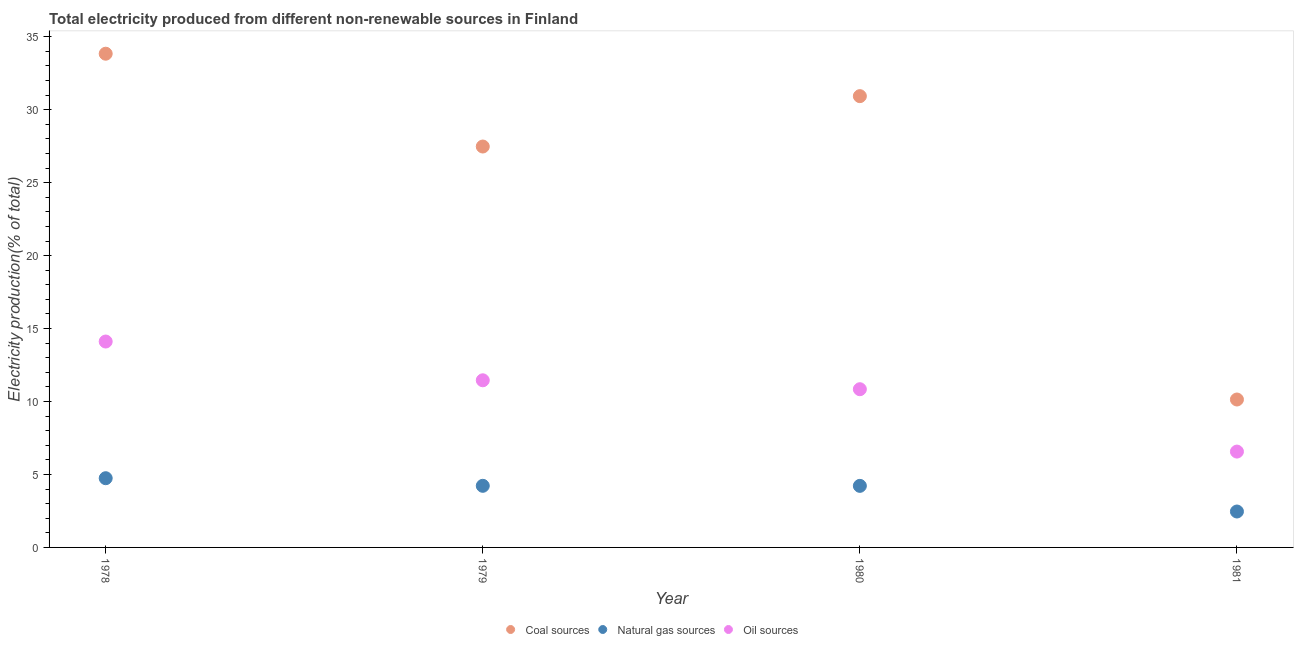What is the percentage of electricity produced by coal in 1981?
Your response must be concise. 10.14. Across all years, what is the maximum percentage of electricity produced by coal?
Offer a very short reply. 33.84. Across all years, what is the minimum percentage of electricity produced by natural gas?
Your response must be concise. 2.46. In which year was the percentage of electricity produced by natural gas maximum?
Provide a succinct answer. 1978. What is the total percentage of electricity produced by natural gas in the graph?
Your answer should be very brief. 15.65. What is the difference between the percentage of electricity produced by oil sources in 1980 and that in 1981?
Your answer should be compact. 4.27. What is the difference between the percentage of electricity produced by natural gas in 1979 and the percentage of electricity produced by coal in 1978?
Provide a short and direct response. -29.61. What is the average percentage of electricity produced by coal per year?
Provide a short and direct response. 25.59. In the year 1978, what is the difference between the percentage of electricity produced by natural gas and percentage of electricity produced by coal?
Give a very brief answer. -29.09. What is the ratio of the percentage of electricity produced by coal in 1979 to that in 1980?
Your answer should be compact. 0.89. Is the difference between the percentage of electricity produced by oil sources in 1980 and 1981 greater than the difference between the percentage of electricity produced by natural gas in 1980 and 1981?
Provide a short and direct response. Yes. What is the difference between the highest and the second highest percentage of electricity produced by coal?
Give a very brief answer. 2.91. What is the difference between the highest and the lowest percentage of electricity produced by coal?
Make the answer very short. 23.7. In how many years, is the percentage of electricity produced by oil sources greater than the average percentage of electricity produced by oil sources taken over all years?
Keep it short and to the point. 3. Is the sum of the percentage of electricity produced by natural gas in 1978 and 1979 greater than the maximum percentage of electricity produced by coal across all years?
Give a very brief answer. No. Is the percentage of electricity produced by natural gas strictly greater than the percentage of electricity produced by oil sources over the years?
Provide a short and direct response. No. How many years are there in the graph?
Make the answer very short. 4. What is the difference between two consecutive major ticks on the Y-axis?
Your answer should be very brief. 5. Are the values on the major ticks of Y-axis written in scientific E-notation?
Give a very brief answer. No. Does the graph contain any zero values?
Provide a succinct answer. No. Does the graph contain grids?
Give a very brief answer. No. Where does the legend appear in the graph?
Your response must be concise. Bottom center. How are the legend labels stacked?
Give a very brief answer. Horizontal. What is the title of the graph?
Offer a terse response. Total electricity produced from different non-renewable sources in Finland. Does "Ages 15-20" appear as one of the legend labels in the graph?
Your response must be concise. No. What is the Electricity production(% of total) in Coal sources in 1978?
Your answer should be compact. 33.84. What is the Electricity production(% of total) of Natural gas sources in 1978?
Ensure brevity in your answer.  4.74. What is the Electricity production(% of total) in Oil sources in 1978?
Keep it short and to the point. 14.11. What is the Electricity production(% of total) in Coal sources in 1979?
Keep it short and to the point. 27.47. What is the Electricity production(% of total) in Natural gas sources in 1979?
Your answer should be compact. 4.22. What is the Electricity production(% of total) in Oil sources in 1979?
Offer a very short reply. 11.45. What is the Electricity production(% of total) in Coal sources in 1980?
Ensure brevity in your answer.  30.93. What is the Electricity production(% of total) in Natural gas sources in 1980?
Give a very brief answer. 4.22. What is the Electricity production(% of total) in Oil sources in 1980?
Ensure brevity in your answer.  10.84. What is the Electricity production(% of total) in Coal sources in 1981?
Your response must be concise. 10.14. What is the Electricity production(% of total) in Natural gas sources in 1981?
Your response must be concise. 2.46. What is the Electricity production(% of total) of Oil sources in 1981?
Provide a succinct answer. 6.57. Across all years, what is the maximum Electricity production(% of total) in Coal sources?
Make the answer very short. 33.84. Across all years, what is the maximum Electricity production(% of total) of Natural gas sources?
Your answer should be very brief. 4.74. Across all years, what is the maximum Electricity production(% of total) in Oil sources?
Offer a terse response. 14.11. Across all years, what is the minimum Electricity production(% of total) of Coal sources?
Keep it short and to the point. 10.14. Across all years, what is the minimum Electricity production(% of total) in Natural gas sources?
Offer a very short reply. 2.46. Across all years, what is the minimum Electricity production(% of total) in Oil sources?
Your answer should be very brief. 6.57. What is the total Electricity production(% of total) of Coal sources in the graph?
Your answer should be compact. 102.37. What is the total Electricity production(% of total) in Natural gas sources in the graph?
Offer a terse response. 15.65. What is the total Electricity production(% of total) of Oil sources in the graph?
Your response must be concise. 42.98. What is the difference between the Electricity production(% of total) of Coal sources in 1978 and that in 1979?
Provide a succinct answer. 6.36. What is the difference between the Electricity production(% of total) of Natural gas sources in 1978 and that in 1979?
Your response must be concise. 0.52. What is the difference between the Electricity production(% of total) of Oil sources in 1978 and that in 1979?
Offer a very short reply. 2.66. What is the difference between the Electricity production(% of total) of Coal sources in 1978 and that in 1980?
Provide a succinct answer. 2.91. What is the difference between the Electricity production(% of total) in Natural gas sources in 1978 and that in 1980?
Offer a terse response. 0.52. What is the difference between the Electricity production(% of total) in Oil sources in 1978 and that in 1980?
Offer a terse response. 3.27. What is the difference between the Electricity production(% of total) of Coal sources in 1978 and that in 1981?
Keep it short and to the point. 23.7. What is the difference between the Electricity production(% of total) of Natural gas sources in 1978 and that in 1981?
Offer a very short reply. 2.28. What is the difference between the Electricity production(% of total) in Oil sources in 1978 and that in 1981?
Your response must be concise. 7.54. What is the difference between the Electricity production(% of total) in Coal sources in 1979 and that in 1980?
Ensure brevity in your answer.  -3.45. What is the difference between the Electricity production(% of total) in Natural gas sources in 1979 and that in 1980?
Offer a terse response. 0. What is the difference between the Electricity production(% of total) of Oil sources in 1979 and that in 1980?
Ensure brevity in your answer.  0.61. What is the difference between the Electricity production(% of total) in Coal sources in 1979 and that in 1981?
Make the answer very short. 17.34. What is the difference between the Electricity production(% of total) in Natural gas sources in 1979 and that in 1981?
Provide a short and direct response. 1.76. What is the difference between the Electricity production(% of total) of Oil sources in 1979 and that in 1981?
Give a very brief answer. 4.89. What is the difference between the Electricity production(% of total) in Coal sources in 1980 and that in 1981?
Make the answer very short. 20.79. What is the difference between the Electricity production(% of total) in Natural gas sources in 1980 and that in 1981?
Make the answer very short. 1.76. What is the difference between the Electricity production(% of total) in Oil sources in 1980 and that in 1981?
Provide a short and direct response. 4.27. What is the difference between the Electricity production(% of total) in Coal sources in 1978 and the Electricity production(% of total) in Natural gas sources in 1979?
Keep it short and to the point. 29.61. What is the difference between the Electricity production(% of total) in Coal sources in 1978 and the Electricity production(% of total) in Oil sources in 1979?
Provide a succinct answer. 22.38. What is the difference between the Electricity production(% of total) of Natural gas sources in 1978 and the Electricity production(% of total) of Oil sources in 1979?
Offer a terse response. -6.71. What is the difference between the Electricity production(% of total) of Coal sources in 1978 and the Electricity production(% of total) of Natural gas sources in 1980?
Provide a succinct answer. 29.62. What is the difference between the Electricity production(% of total) in Coal sources in 1978 and the Electricity production(% of total) in Oil sources in 1980?
Offer a terse response. 22.99. What is the difference between the Electricity production(% of total) of Natural gas sources in 1978 and the Electricity production(% of total) of Oil sources in 1980?
Ensure brevity in your answer.  -6.1. What is the difference between the Electricity production(% of total) of Coal sources in 1978 and the Electricity production(% of total) of Natural gas sources in 1981?
Ensure brevity in your answer.  31.37. What is the difference between the Electricity production(% of total) of Coal sources in 1978 and the Electricity production(% of total) of Oil sources in 1981?
Provide a short and direct response. 27.27. What is the difference between the Electricity production(% of total) of Natural gas sources in 1978 and the Electricity production(% of total) of Oil sources in 1981?
Provide a succinct answer. -1.82. What is the difference between the Electricity production(% of total) in Coal sources in 1979 and the Electricity production(% of total) in Natural gas sources in 1980?
Provide a short and direct response. 23.26. What is the difference between the Electricity production(% of total) in Coal sources in 1979 and the Electricity production(% of total) in Oil sources in 1980?
Offer a terse response. 16.63. What is the difference between the Electricity production(% of total) in Natural gas sources in 1979 and the Electricity production(% of total) in Oil sources in 1980?
Your answer should be very brief. -6.62. What is the difference between the Electricity production(% of total) of Coal sources in 1979 and the Electricity production(% of total) of Natural gas sources in 1981?
Your answer should be very brief. 25.01. What is the difference between the Electricity production(% of total) in Coal sources in 1979 and the Electricity production(% of total) in Oil sources in 1981?
Provide a succinct answer. 20.91. What is the difference between the Electricity production(% of total) of Natural gas sources in 1979 and the Electricity production(% of total) of Oil sources in 1981?
Provide a succinct answer. -2.35. What is the difference between the Electricity production(% of total) of Coal sources in 1980 and the Electricity production(% of total) of Natural gas sources in 1981?
Give a very brief answer. 28.47. What is the difference between the Electricity production(% of total) in Coal sources in 1980 and the Electricity production(% of total) in Oil sources in 1981?
Ensure brevity in your answer.  24.36. What is the difference between the Electricity production(% of total) of Natural gas sources in 1980 and the Electricity production(% of total) of Oil sources in 1981?
Your answer should be compact. -2.35. What is the average Electricity production(% of total) in Coal sources per year?
Keep it short and to the point. 25.59. What is the average Electricity production(% of total) of Natural gas sources per year?
Your answer should be very brief. 3.91. What is the average Electricity production(% of total) of Oil sources per year?
Make the answer very short. 10.74. In the year 1978, what is the difference between the Electricity production(% of total) of Coal sources and Electricity production(% of total) of Natural gas sources?
Offer a terse response. 29.09. In the year 1978, what is the difference between the Electricity production(% of total) of Coal sources and Electricity production(% of total) of Oil sources?
Provide a succinct answer. 19.72. In the year 1978, what is the difference between the Electricity production(% of total) in Natural gas sources and Electricity production(% of total) in Oil sources?
Keep it short and to the point. -9.37. In the year 1979, what is the difference between the Electricity production(% of total) of Coal sources and Electricity production(% of total) of Natural gas sources?
Your response must be concise. 23.25. In the year 1979, what is the difference between the Electricity production(% of total) of Coal sources and Electricity production(% of total) of Oil sources?
Provide a short and direct response. 16.02. In the year 1979, what is the difference between the Electricity production(% of total) of Natural gas sources and Electricity production(% of total) of Oil sources?
Offer a terse response. -7.23. In the year 1980, what is the difference between the Electricity production(% of total) in Coal sources and Electricity production(% of total) in Natural gas sources?
Give a very brief answer. 26.71. In the year 1980, what is the difference between the Electricity production(% of total) of Coal sources and Electricity production(% of total) of Oil sources?
Make the answer very short. 20.08. In the year 1980, what is the difference between the Electricity production(% of total) of Natural gas sources and Electricity production(% of total) of Oil sources?
Your answer should be compact. -6.62. In the year 1981, what is the difference between the Electricity production(% of total) in Coal sources and Electricity production(% of total) in Natural gas sources?
Ensure brevity in your answer.  7.68. In the year 1981, what is the difference between the Electricity production(% of total) of Coal sources and Electricity production(% of total) of Oil sources?
Offer a terse response. 3.57. In the year 1981, what is the difference between the Electricity production(% of total) of Natural gas sources and Electricity production(% of total) of Oil sources?
Give a very brief answer. -4.11. What is the ratio of the Electricity production(% of total) in Coal sources in 1978 to that in 1979?
Provide a short and direct response. 1.23. What is the ratio of the Electricity production(% of total) of Natural gas sources in 1978 to that in 1979?
Give a very brief answer. 1.12. What is the ratio of the Electricity production(% of total) in Oil sources in 1978 to that in 1979?
Provide a succinct answer. 1.23. What is the ratio of the Electricity production(% of total) of Coal sources in 1978 to that in 1980?
Your answer should be very brief. 1.09. What is the ratio of the Electricity production(% of total) of Natural gas sources in 1978 to that in 1980?
Keep it short and to the point. 1.12. What is the ratio of the Electricity production(% of total) of Oil sources in 1978 to that in 1980?
Offer a very short reply. 1.3. What is the ratio of the Electricity production(% of total) in Coal sources in 1978 to that in 1981?
Your response must be concise. 3.34. What is the ratio of the Electricity production(% of total) of Natural gas sources in 1978 to that in 1981?
Your answer should be very brief. 1.93. What is the ratio of the Electricity production(% of total) of Oil sources in 1978 to that in 1981?
Provide a succinct answer. 2.15. What is the ratio of the Electricity production(% of total) of Coal sources in 1979 to that in 1980?
Keep it short and to the point. 0.89. What is the ratio of the Electricity production(% of total) of Oil sources in 1979 to that in 1980?
Your answer should be compact. 1.06. What is the ratio of the Electricity production(% of total) of Coal sources in 1979 to that in 1981?
Make the answer very short. 2.71. What is the ratio of the Electricity production(% of total) of Natural gas sources in 1979 to that in 1981?
Offer a terse response. 1.72. What is the ratio of the Electricity production(% of total) in Oil sources in 1979 to that in 1981?
Ensure brevity in your answer.  1.74. What is the ratio of the Electricity production(% of total) in Coal sources in 1980 to that in 1981?
Ensure brevity in your answer.  3.05. What is the ratio of the Electricity production(% of total) of Natural gas sources in 1980 to that in 1981?
Your response must be concise. 1.71. What is the ratio of the Electricity production(% of total) of Oil sources in 1980 to that in 1981?
Give a very brief answer. 1.65. What is the difference between the highest and the second highest Electricity production(% of total) in Coal sources?
Your response must be concise. 2.91. What is the difference between the highest and the second highest Electricity production(% of total) of Natural gas sources?
Keep it short and to the point. 0.52. What is the difference between the highest and the second highest Electricity production(% of total) of Oil sources?
Your answer should be very brief. 2.66. What is the difference between the highest and the lowest Electricity production(% of total) of Coal sources?
Give a very brief answer. 23.7. What is the difference between the highest and the lowest Electricity production(% of total) of Natural gas sources?
Your answer should be compact. 2.28. What is the difference between the highest and the lowest Electricity production(% of total) in Oil sources?
Your response must be concise. 7.54. 